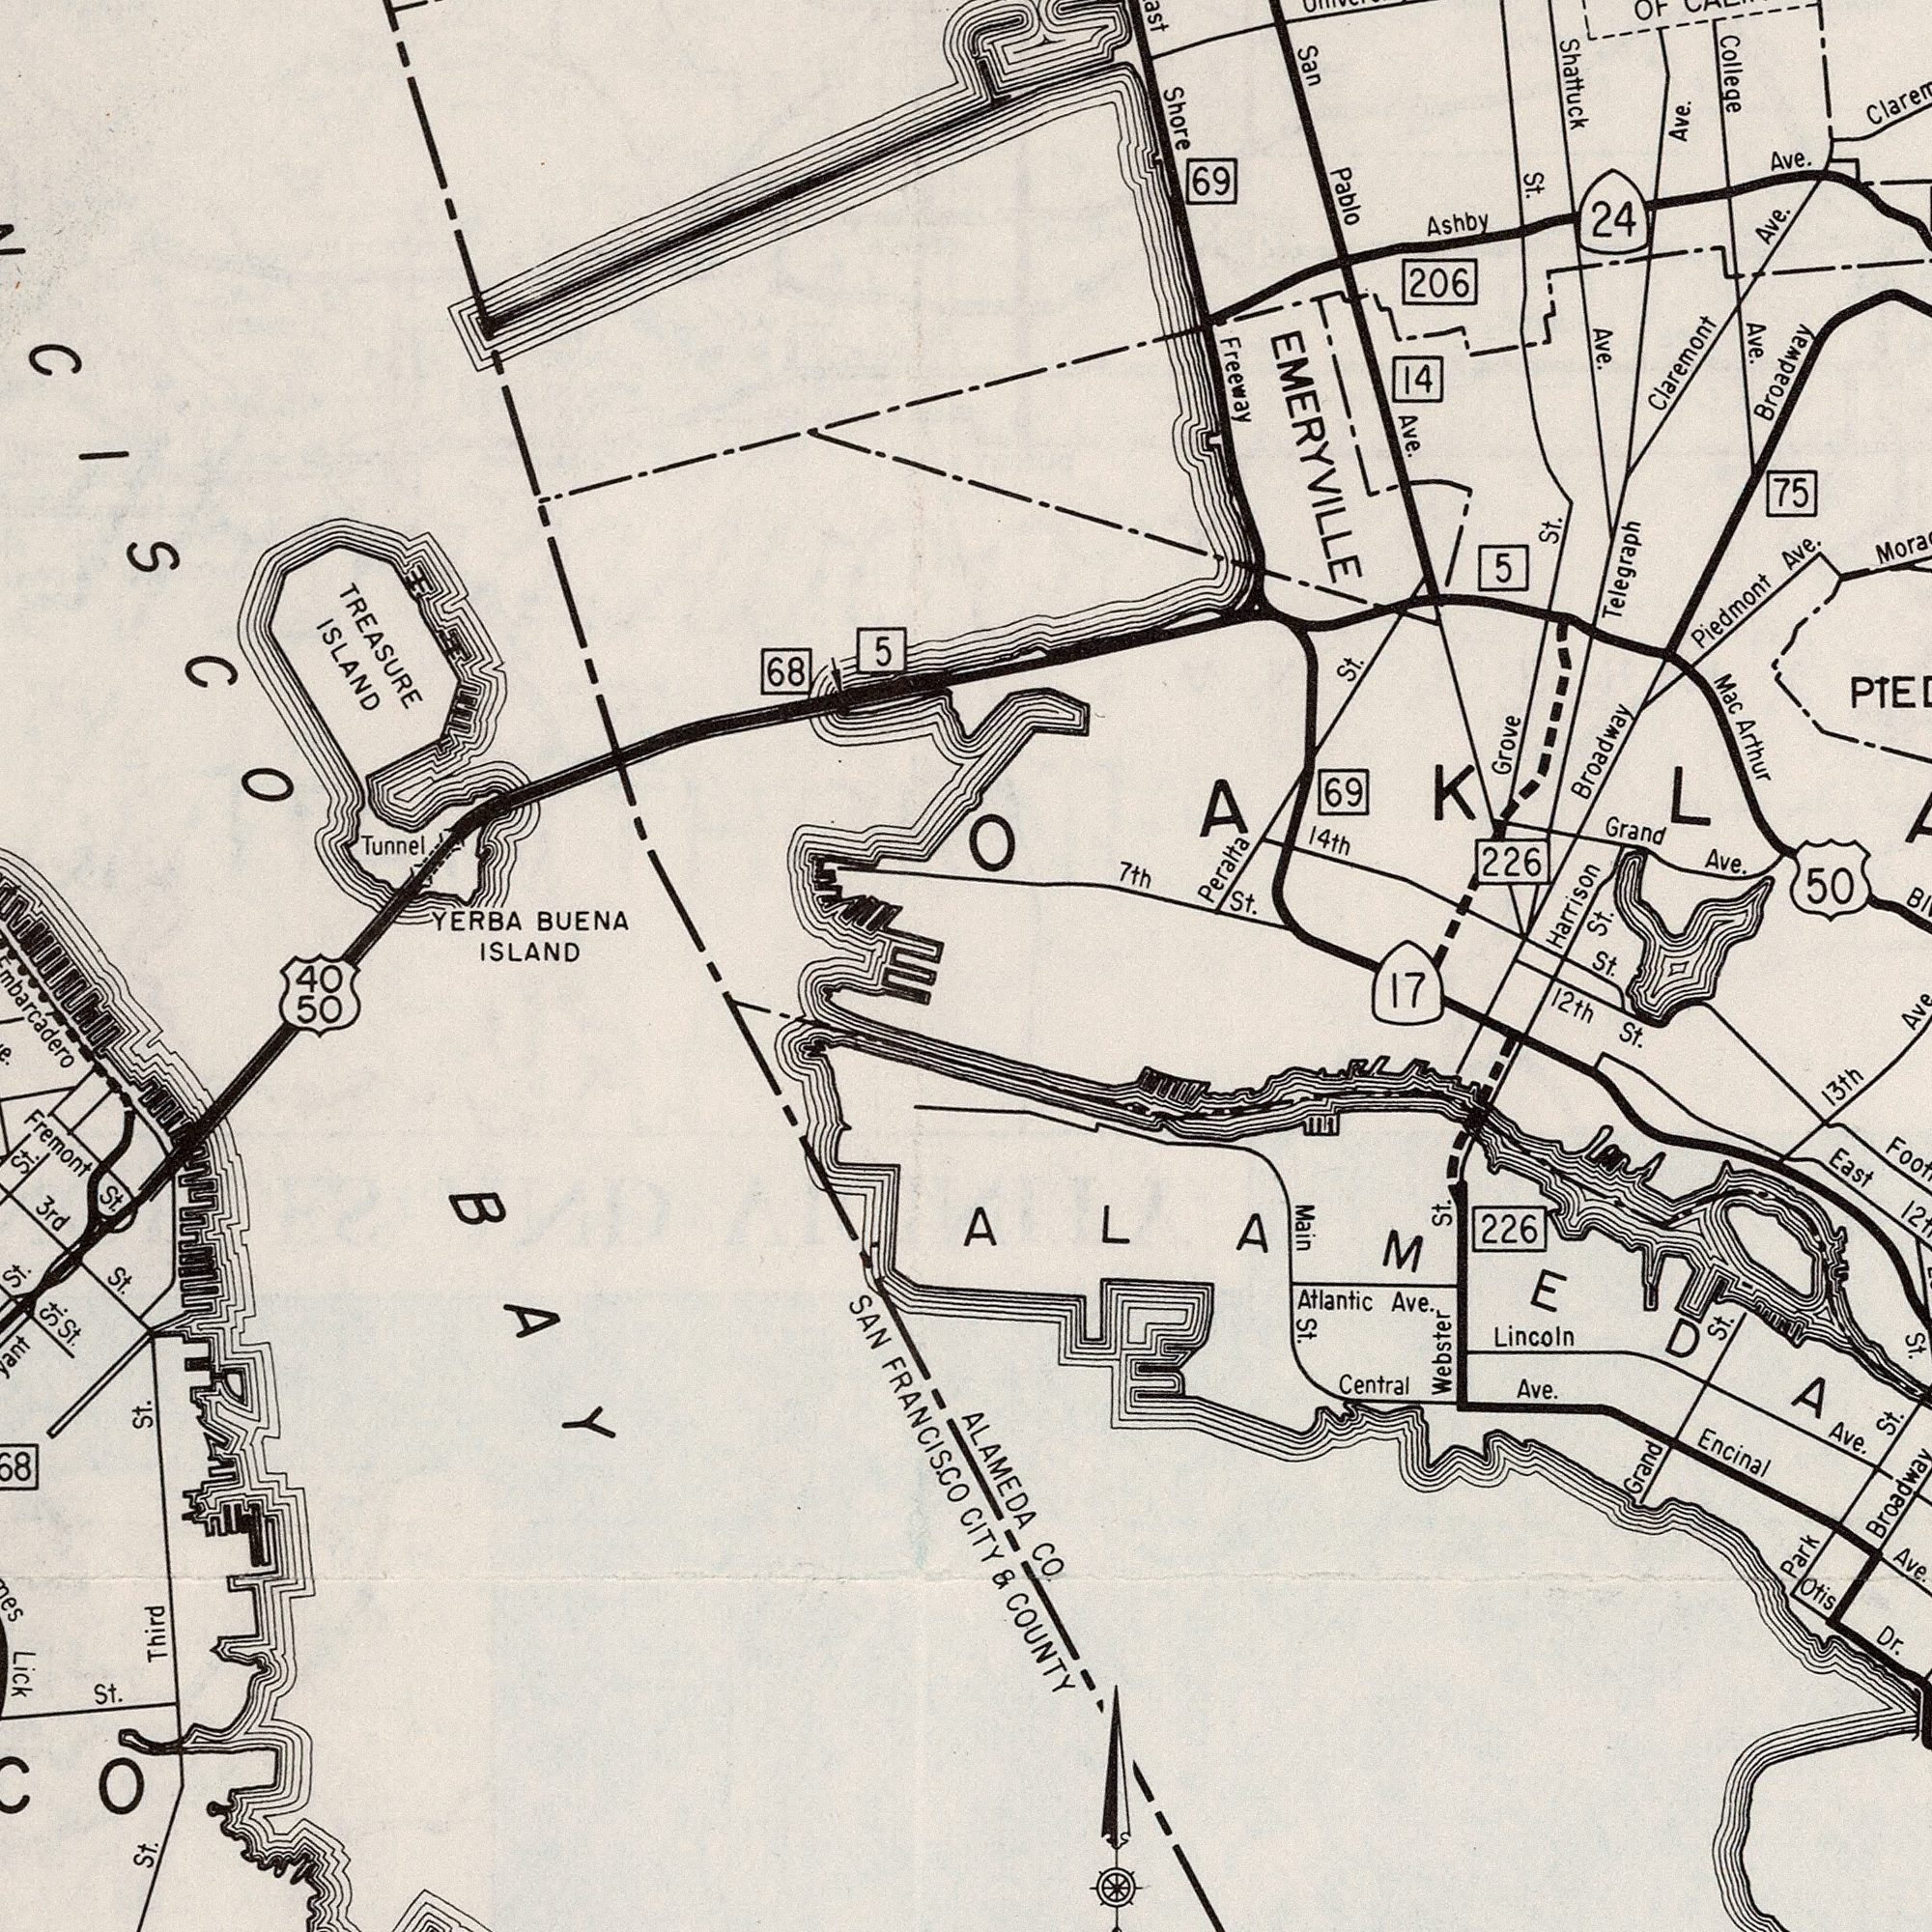What text can you see in the bottom-left section? 3rd Lick FRANCISCO St. Fremont Third SAN St. St. St. 50 St St. 68 St. 40 BAY St. St. What text appears in the top-right area of the image? College Shattuck Ave. St. Grove Ave. EMERYVILLE Freeway Arthur 226 75 Telegraph Piedmont Shore Ave. Claremont 50 St. Ave. Ave. Grand Pablo Ave. 69 24 St. 206 7th Ave. 69 Mac 14th 5 St. Ashby Broadway St. Harrison 14 Broadway San Peralta Ave. What text is shown in the bottom-right quadrant? Main Ave. St. 13th Encinal Webster St. Ave. 17 226 Lincoln St. CO. Atlantic Ave. Central Ave St. St. Otis Park Broadway St. Dr. 12th Grand COUNTY Ave. 12th & ALAMEDA East CITY St. What text appears in the top-left area of the image? TREASURE ISLAND ISLAND YERBA BUENA 68 5 Tunnel 